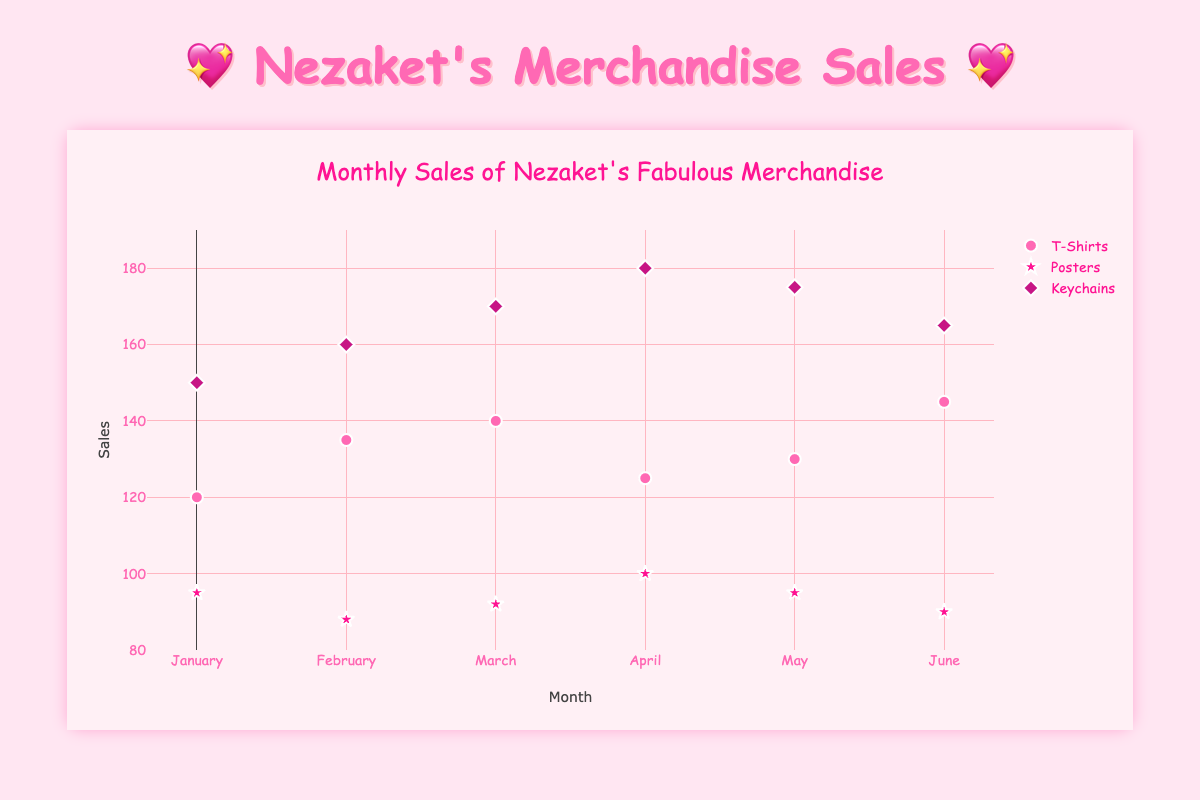What is the title of the figure? The title is usually displayed prominently at the top of the figure. In this case, it's written in a large font size and describes the overall subject of the figure.
Answer: Monthly Sales of Nezaket's Fabulous Merchandise How many different product types are displayed in the scatter plot? The scatter plot separates data points visually based on product types, which are usually highlighted in the legend on the right. In this case, the plot displays data points with symbols and colors corresponding to different product types.
Answer: 3 Which month had the highest sales for T-Shirts? To find this, look at the data points for T-Shirts, identified by their unique color and/or symbol. Then compare the y-values (sales) across different months.
Answer: June For which month did Keychains have the least sales? Identify the data points representing Keychains by their color and/or symbol. Then find the month where the y-value (sales) is the lowest.
Answer: January How do the sales of Posters in May compare to those in April? Find the data points for Posters in May and April, and compare their y-values (sales).
Answer: Sales were the same in both May and April What is the average sales figure for T-Shirts over these months? To calculate the average, sum up the sales figures for T-Shirts from each month and divide by the number of months (6). Sum: 120 + 135 + 140 + 125 + 130 + 145 = 795. Then, 795 / 6.
Answer: 132.5 Which product had the highest sales in April? Look at the sales figures (y-values) for each product type in April and identify which one has the highest sales.
Answer: Keychains By how much did Keychain sales increase from January to April? Find the sales figures for Keychains in January and April. Subtract the January figure from the April figure. 180 - 150 = 30.
Answer: 30 In which month did Posters reach their peak sales? Identify the data points for Posters for each month and find the highest y-value (sales).
Answer: April Which product type shows the most consistent sales trend across the months? Compare the data points for each product type across months. The product whose sales figures (y-values) fluctuate the least can be considered the most consistent.
Answer: T-Shirts 